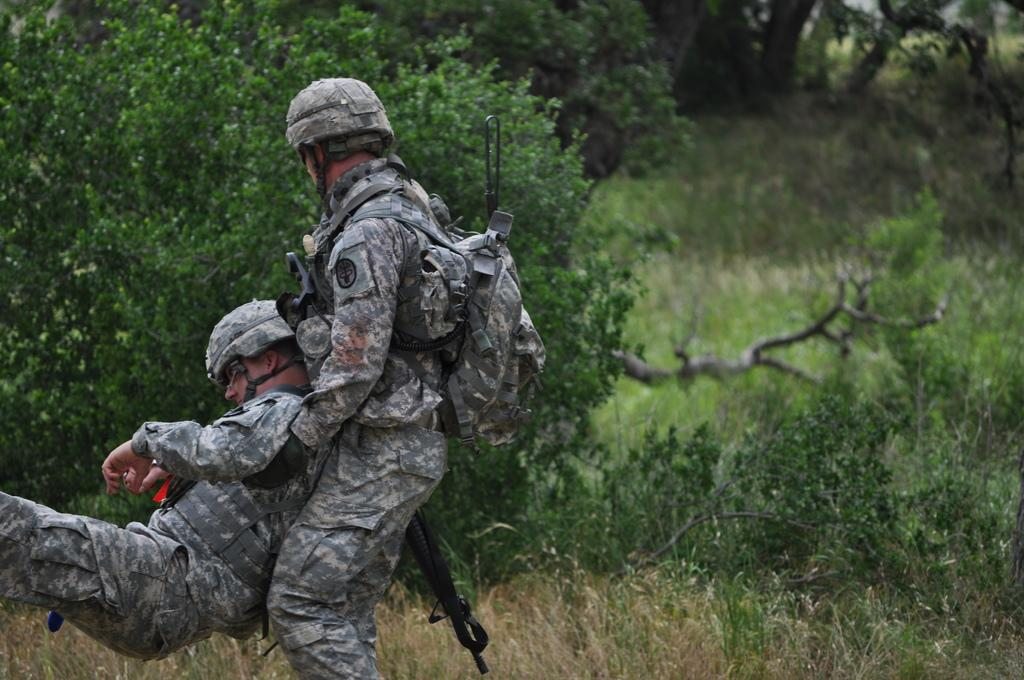How many people are present in the image? There are two people in the image. What are the people wearing in the image? The two people are wearing military uniforms. What can be seen in the background of the image? There are trees in the background of the image. What type of vessel can be seen in the image? There is no vessel present in the image. How do the giants interact with the trees in the image? There are no giants present in the image, so their interaction with the trees cannot be observed. 